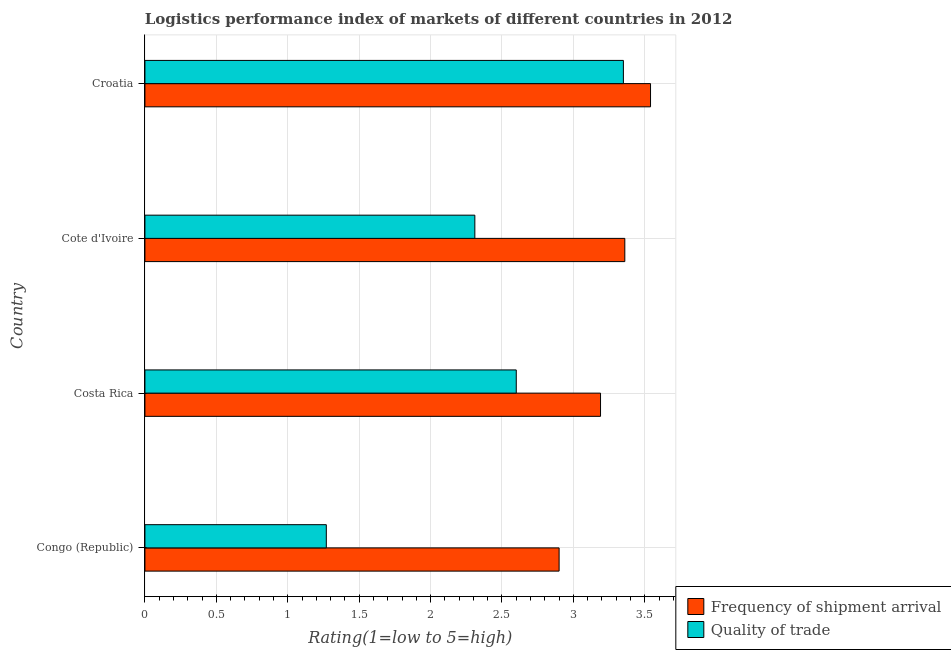How many different coloured bars are there?
Offer a terse response. 2. Are the number of bars per tick equal to the number of legend labels?
Give a very brief answer. Yes. What is the label of the 2nd group of bars from the top?
Offer a very short reply. Cote d'Ivoire. In how many cases, is the number of bars for a given country not equal to the number of legend labels?
Provide a short and direct response. 0. What is the lpi of frequency of shipment arrival in Costa Rica?
Your answer should be very brief. 3.19. Across all countries, what is the maximum lpi quality of trade?
Offer a very short reply. 3.35. Across all countries, what is the minimum lpi quality of trade?
Keep it short and to the point. 1.27. In which country was the lpi of frequency of shipment arrival maximum?
Make the answer very short. Croatia. In which country was the lpi of frequency of shipment arrival minimum?
Keep it short and to the point. Congo (Republic). What is the total lpi quality of trade in the graph?
Your answer should be compact. 9.53. What is the difference between the lpi of frequency of shipment arrival in Congo (Republic) and that in Costa Rica?
Ensure brevity in your answer.  -0.29. What is the difference between the lpi of frequency of shipment arrival in Cote d'Ivoire and the lpi quality of trade in Congo (Republic)?
Provide a succinct answer. 2.09. What is the average lpi of frequency of shipment arrival per country?
Provide a succinct answer. 3.25. What is the difference between the lpi of frequency of shipment arrival and lpi quality of trade in Costa Rica?
Provide a short and direct response. 0.59. In how many countries, is the lpi quality of trade greater than 1.9 ?
Provide a short and direct response. 3. What is the ratio of the lpi of frequency of shipment arrival in Congo (Republic) to that in Croatia?
Offer a very short reply. 0.82. Is the difference between the lpi quality of trade in Congo (Republic) and Cote d'Ivoire greater than the difference between the lpi of frequency of shipment arrival in Congo (Republic) and Cote d'Ivoire?
Provide a short and direct response. No. What is the difference between the highest and the second highest lpi quality of trade?
Your response must be concise. 0.75. What is the difference between the highest and the lowest lpi of frequency of shipment arrival?
Your answer should be very brief. 0.64. In how many countries, is the lpi of frequency of shipment arrival greater than the average lpi of frequency of shipment arrival taken over all countries?
Your answer should be very brief. 2. Is the sum of the lpi quality of trade in Congo (Republic) and Cote d'Ivoire greater than the maximum lpi of frequency of shipment arrival across all countries?
Offer a terse response. Yes. What does the 1st bar from the top in Cote d'Ivoire represents?
Your answer should be very brief. Quality of trade. What does the 2nd bar from the bottom in Congo (Republic) represents?
Offer a very short reply. Quality of trade. Are all the bars in the graph horizontal?
Your response must be concise. Yes. What is the difference between two consecutive major ticks on the X-axis?
Ensure brevity in your answer.  0.5. Does the graph contain any zero values?
Your response must be concise. No. Does the graph contain grids?
Your response must be concise. Yes. Where does the legend appear in the graph?
Provide a short and direct response. Bottom right. How are the legend labels stacked?
Your answer should be very brief. Vertical. What is the title of the graph?
Offer a terse response. Logistics performance index of markets of different countries in 2012. What is the label or title of the X-axis?
Offer a very short reply. Rating(1=low to 5=high). What is the label or title of the Y-axis?
Your response must be concise. Country. What is the Rating(1=low to 5=high) in Quality of trade in Congo (Republic)?
Give a very brief answer. 1.27. What is the Rating(1=low to 5=high) in Frequency of shipment arrival in Costa Rica?
Provide a short and direct response. 3.19. What is the Rating(1=low to 5=high) of Frequency of shipment arrival in Cote d'Ivoire?
Provide a short and direct response. 3.36. What is the Rating(1=low to 5=high) in Quality of trade in Cote d'Ivoire?
Your response must be concise. 2.31. What is the Rating(1=low to 5=high) in Frequency of shipment arrival in Croatia?
Offer a terse response. 3.54. What is the Rating(1=low to 5=high) in Quality of trade in Croatia?
Offer a very short reply. 3.35. Across all countries, what is the maximum Rating(1=low to 5=high) in Frequency of shipment arrival?
Your response must be concise. 3.54. Across all countries, what is the maximum Rating(1=low to 5=high) in Quality of trade?
Give a very brief answer. 3.35. Across all countries, what is the minimum Rating(1=low to 5=high) of Quality of trade?
Provide a succinct answer. 1.27. What is the total Rating(1=low to 5=high) in Frequency of shipment arrival in the graph?
Your answer should be compact. 12.99. What is the total Rating(1=low to 5=high) in Quality of trade in the graph?
Make the answer very short. 9.53. What is the difference between the Rating(1=low to 5=high) in Frequency of shipment arrival in Congo (Republic) and that in Costa Rica?
Your answer should be compact. -0.29. What is the difference between the Rating(1=low to 5=high) in Quality of trade in Congo (Republic) and that in Costa Rica?
Your answer should be very brief. -1.33. What is the difference between the Rating(1=low to 5=high) of Frequency of shipment arrival in Congo (Republic) and that in Cote d'Ivoire?
Provide a short and direct response. -0.46. What is the difference between the Rating(1=low to 5=high) of Quality of trade in Congo (Republic) and that in Cote d'Ivoire?
Your answer should be compact. -1.04. What is the difference between the Rating(1=low to 5=high) in Frequency of shipment arrival in Congo (Republic) and that in Croatia?
Ensure brevity in your answer.  -0.64. What is the difference between the Rating(1=low to 5=high) of Quality of trade in Congo (Republic) and that in Croatia?
Your answer should be very brief. -2.08. What is the difference between the Rating(1=low to 5=high) of Frequency of shipment arrival in Costa Rica and that in Cote d'Ivoire?
Provide a succinct answer. -0.17. What is the difference between the Rating(1=low to 5=high) in Quality of trade in Costa Rica and that in Cote d'Ivoire?
Offer a very short reply. 0.29. What is the difference between the Rating(1=low to 5=high) in Frequency of shipment arrival in Costa Rica and that in Croatia?
Offer a terse response. -0.35. What is the difference between the Rating(1=low to 5=high) of Quality of trade in Costa Rica and that in Croatia?
Ensure brevity in your answer.  -0.75. What is the difference between the Rating(1=low to 5=high) of Frequency of shipment arrival in Cote d'Ivoire and that in Croatia?
Offer a very short reply. -0.18. What is the difference between the Rating(1=low to 5=high) in Quality of trade in Cote d'Ivoire and that in Croatia?
Provide a short and direct response. -1.04. What is the difference between the Rating(1=low to 5=high) in Frequency of shipment arrival in Congo (Republic) and the Rating(1=low to 5=high) in Quality of trade in Cote d'Ivoire?
Provide a short and direct response. 0.59. What is the difference between the Rating(1=low to 5=high) of Frequency of shipment arrival in Congo (Republic) and the Rating(1=low to 5=high) of Quality of trade in Croatia?
Provide a succinct answer. -0.45. What is the difference between the Rating(1=low to 5=high) of Frequency of shipment arrival in Costa Rica and the Rating(1=low to 5=high) of Quality of trade in Croatia?
Offer a very short reply. -0.16. What is the average Rating(1=low to 5=high) of Frequency of shipment arrival per country?
Give a very brief answer. 3.25. What is the average Rating(1=low to 5=high) of Quality of trade per country?
Your response must be concise. 2.38. What is the difference between the Rating(1=low to 5=high) of Frequency of shipment arrival and Rating(1=low to 5=high) of Quality of trade in Congo (Republic)?
Offer a very short reply. 1.63. What is the difference between the Rating(1=low to 5=high) of Frequency of shipment arrival and Rating(1=low to 5=high) of Quality of trade in Costa Rica?
Your answer should be very brief. 0.59. What is the difference between the Rating(1=low to 5=high) in Frequency of shipment arrival and Rating(1=low to 5=high) in Quality of trade in Croatia?
Provide a short and direct response. 0.19. What is the ratio of the Rating(1=low to 5=high) in Frequency of shipment arrival in Congo (Republic) to that in Costa Rica?
Keep it short and to the point. 0.91. What is the ratio of the Rating(1=low to 5=high) in Quality of trade in Congo (Republic) to that in Costa Rica?
Keep it short and to the point. 0.49. What is the ratio of the Rating(1=low to 5=high) of Frequency of shipment arrival in Congo (Republic) to that in Cote d'Ivoire?
Provide a short and direct response. 0.86. What is the ratio of the Rating(1=low to 5=high) in Quality of trade in Congo (Republic) to that in Cote d'Ivoire?
Offer a very short reply. 0.55. What is the ratio of the Rating(1=low to 5=high) in Frequency of shipment arrival in Congo (Republic) to that in Croatia?
Your answer should be compact. 0.82. What is the ratio of the Rating(1=low to 5=high) of Quality of trade in Congo (Republic) to that in Croatia?
Provide a short and direct response. 0.38. What is the ratio of the Rating(1=low to 5=high) of Frequency of shipment arrival in Costa Rica to that in Cote d'Ivoire?
Give a very brief answer. 0.95. What is the ratio of the Rating(1=low to 5=high) of Quality of trade in Costa Rica to that in Cote d'Ivoire?
Ensure brevity in your answer.  1.13. What is the ratio of the Rating(1=low to 5=high) in Frequency of shipment arrival in Costa Rica to that in Croatia?
Keep it short and to the point. 0.9. What is the ratio of the Rating(1=low to 5=high) of Quality of trade in Costa Rica to that in Croatia?
Your response must be concise. 0.78. What is the ratio of the Rating(1=low to 5=high) of Frequency of shipment arrival in Cote d'Ivoire to that in Croatia?
Provide a short and direct response. 0.95. What is the ratio of the Rating(1=low to 5=high) of Quality of trade in Cote d'Ivoire to that in Croatia?
Offer a very short reply. 0.69. What is the difference between the highest and the second highest Rating(1=low to 5=high) in Frequency of shipment arrival?
Keep it short and to the point. 0.18. What is the difference between the highest and the lowest Rating(1=low to 5=high) in Frequency of shipment arrival?
Provide a succinct answer. 0.64. What is the difference between the highest and the lowest Rating(1=low to 5=high) in Quality of trade?
Ensure brevity in your answer.  2.08. 